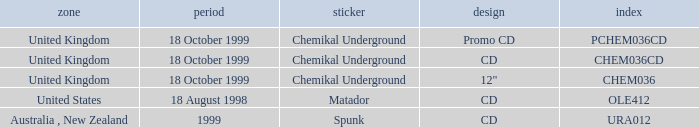What label is associated with the United Kingdom and the chem036 catalog? Chemikal Underground. 